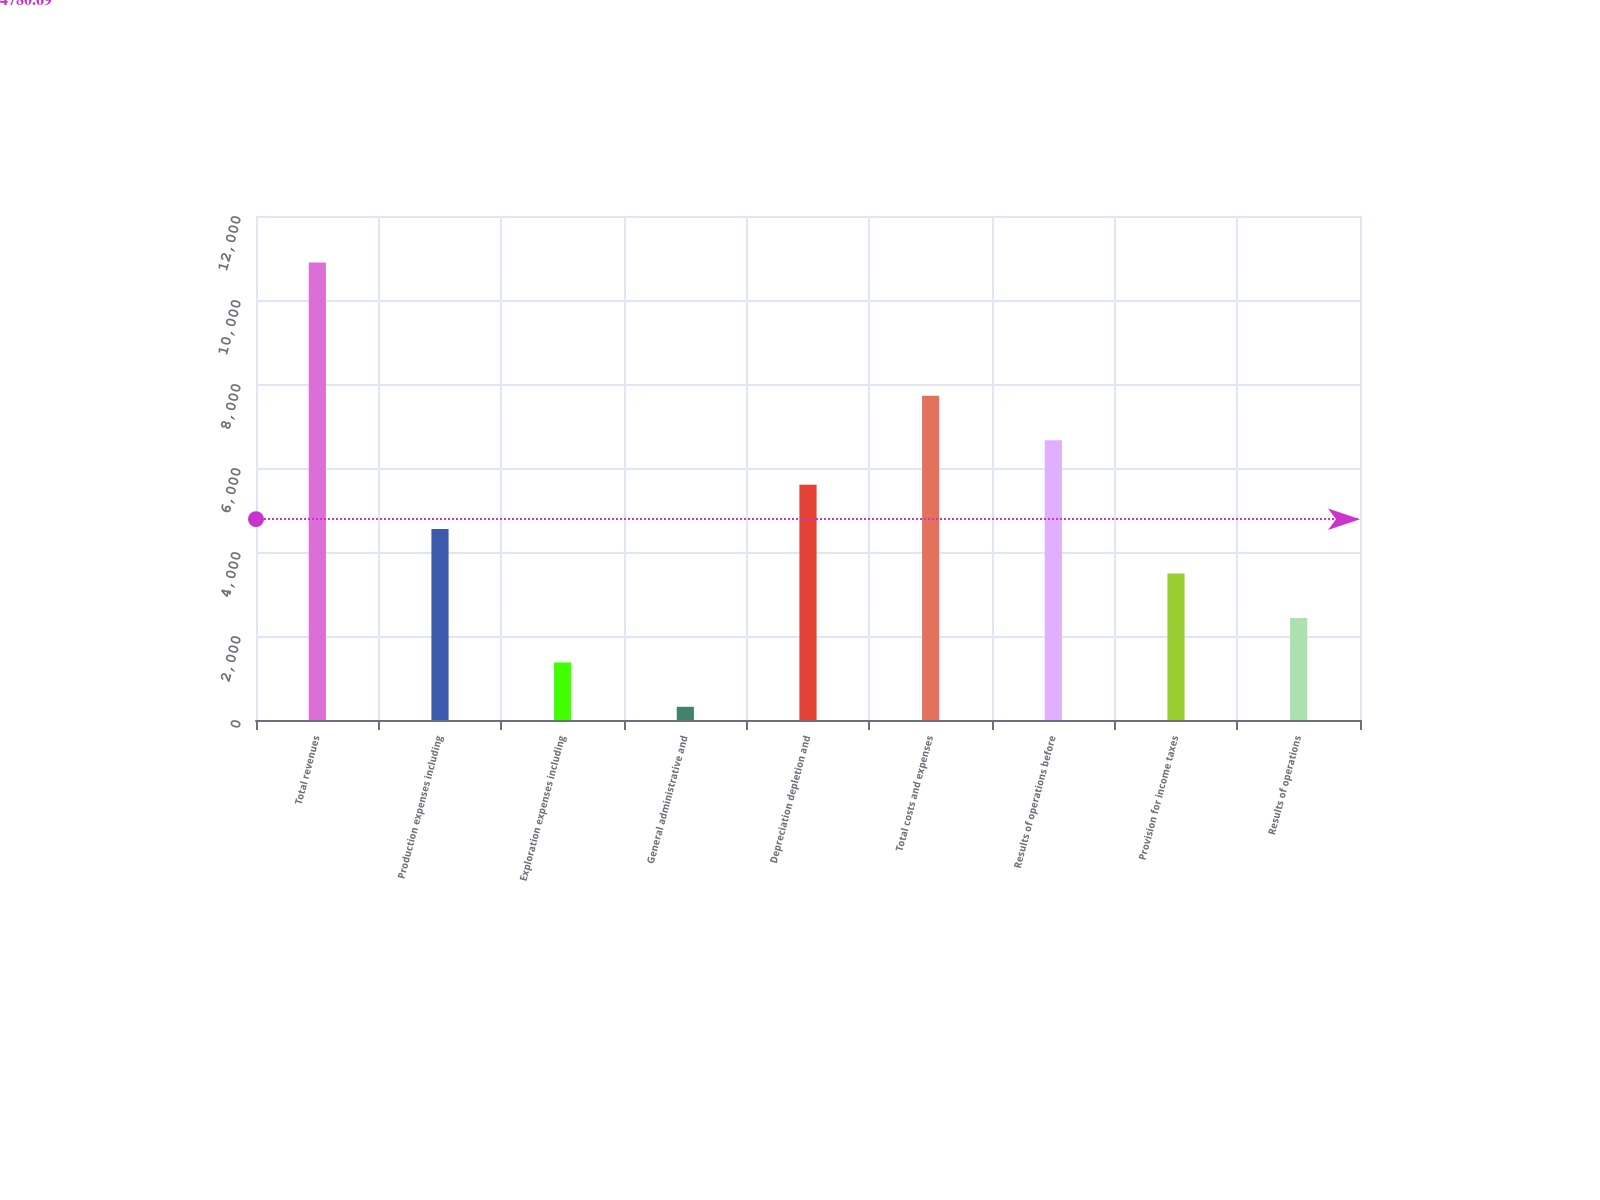<chart> <loc_0><loc_0><loc_500><loc_500><bar_chart><fcel>Total revenues<fcel>Production expenses including<fcel>Exploration expenses including<fcel>General administrative and<fcel>Depreciation depletion and<fcel>Total costs and expenses<fcel>Results of operations before<fcel>Provision for income taxes<fcel>Results of operations<nl><fcel>10893<fcel>4545.6<fcel>1371.9<fcel>314<fcel>5603.5<fcel>7719.3<fcel>6661.4<fcel>3487.7<fcel>2429.8<nl></chart> 